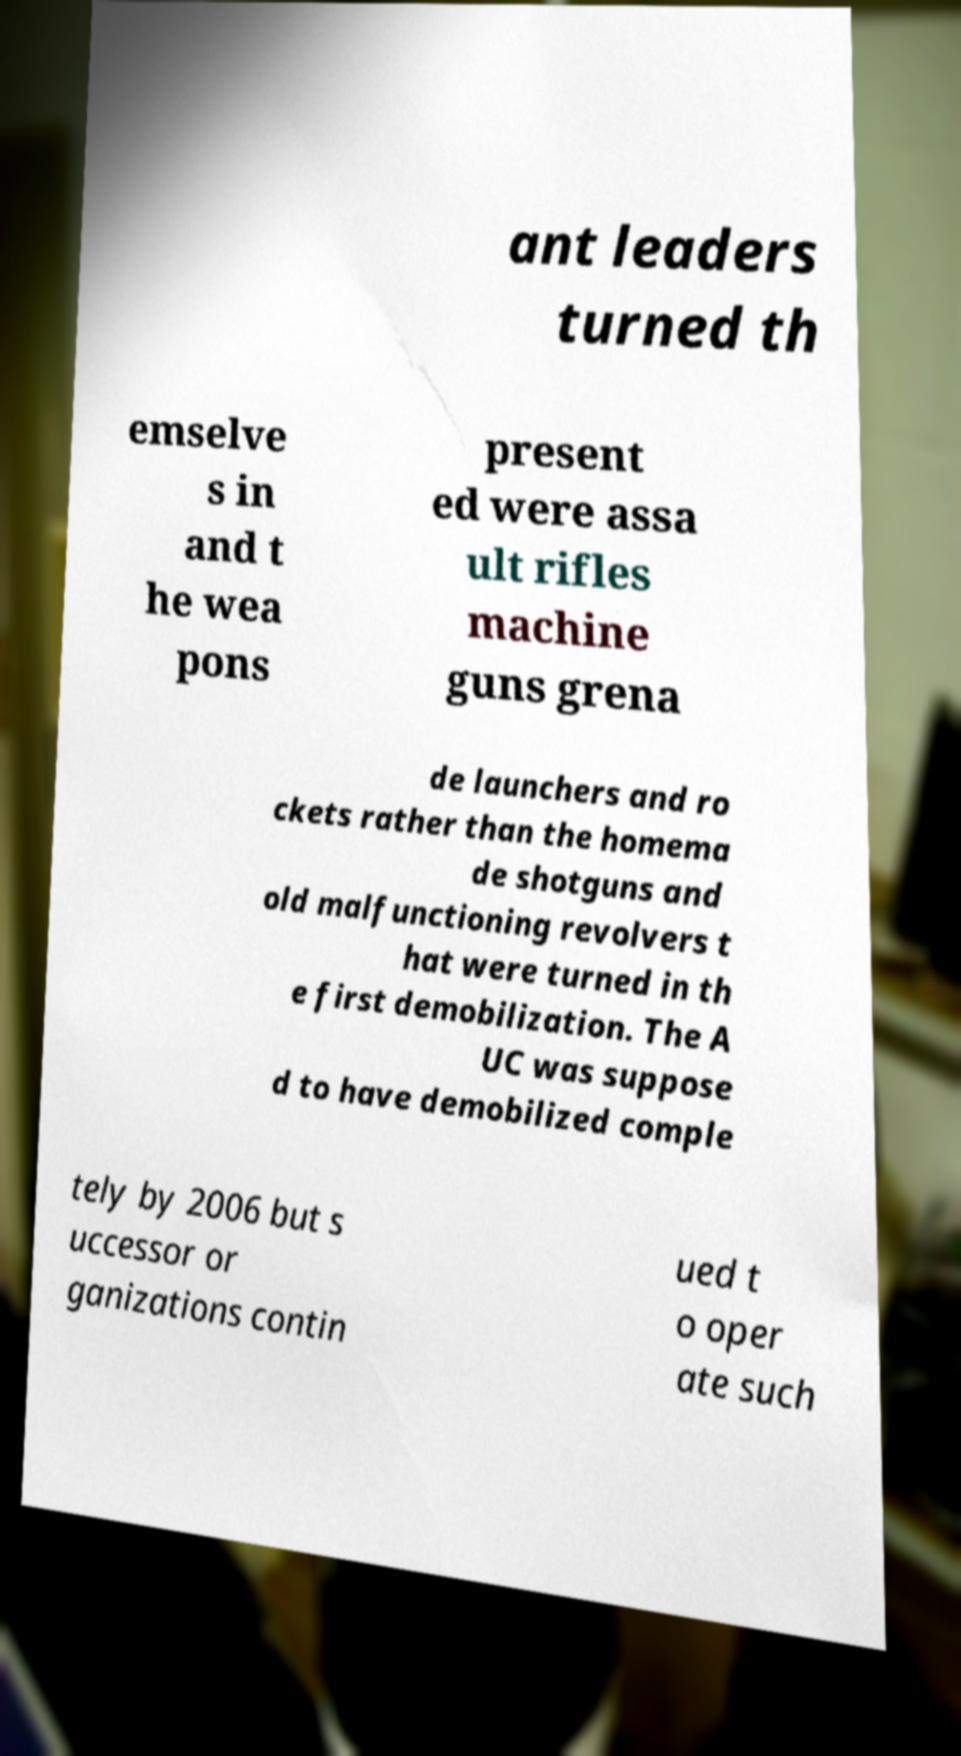Could you extract and type out the text from this image? ant leaders turned th emselve s in and t he wea pons present ed were assa ult rifles machine guns grena de launchers and ro ckets rather than the homema de shotguns and old malfunctioning revolvers t hat were turned in th e first demobilization. The A UC was suppose d to have demobilized comple tely by 2006 but s uccessor or ganizations contin ued t o oper ate such 